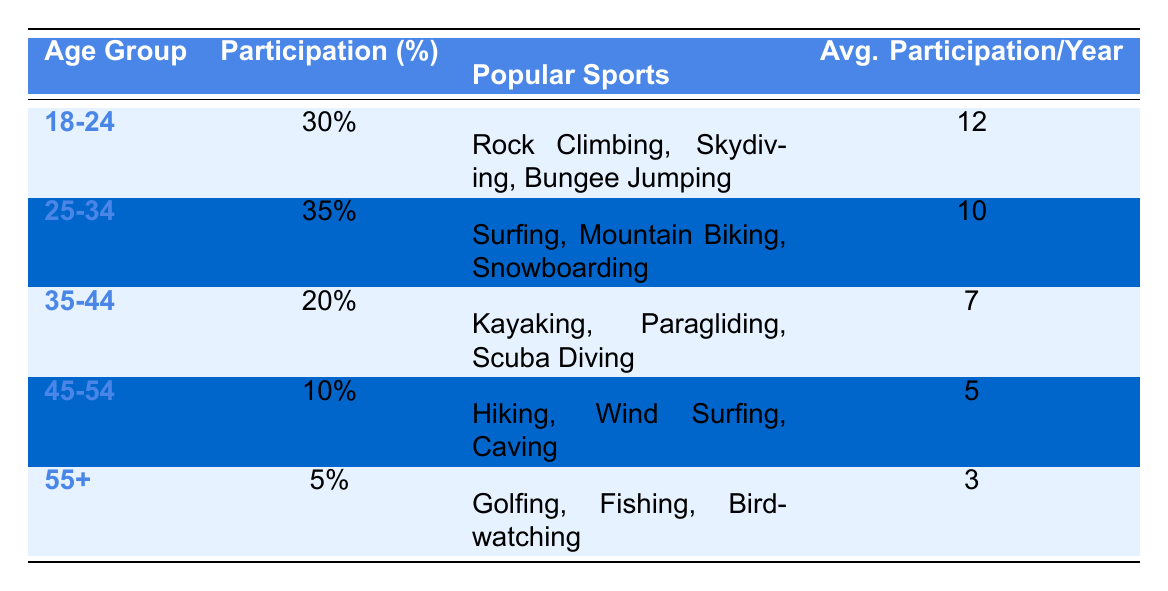What is the participation percentage for the age group 25-34? Looking at the table, under the "Participation (%)" column for the age range "25-34," the percentage listed is 35%.
Answer: 35% Which age group has the highest average participation per year? By examining the "Avg. Participation/Year" column, the age group "18-24" has the highest value at 12.
Answer: 18-24 Is it true that the participation percentage for the age group 45-54 is greater than that for the age group 35-44? The table shows that the percentage for "45-54" is 10% and for "35-44" is 20%. Since 10% is less than 20%, the statement is false.
Answer: No What are the popular sports for the age group 55+? Referring to the "Popular Sports" column for the "55+" age range, the listed sports are Golfing, Fishing, and Birdwatching.
Answer: Golfing, Fishing, Birdwatching What is the average participation per year for the age group with the lowest percentage? The age group with the lowest participation percentage is "55+" with 5%. Referring to the "Avg. Participation/Year" for this group, it is 3.
Answer: 3 Which two age groups have a participation percentage of 20% or lower? Analyzing the participation percentages, "35-44" is 20% and "45-54" is 10%. Therefore, the two groups are "35-44" and "45-54."
Answer: 35-44, 45-54 If you combine the average participation per year of the age groups 25-34 and 35-44, what is the total? The average participation per year for "25-34" is 10 and for "35-44" is 7. Adding these amounts gives 10 + 7 = 17.
Answer: 17 Which age group has the least popular sports? The age group "55+" has the least engagement in adventure sports, as indicated by the low participation percentage (5%).
Answer: 55+ 